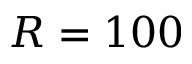Convert formula to latex. <formula><loc_0><loc_0><loc_500><loc_500>R = 1 0 0</formula> 